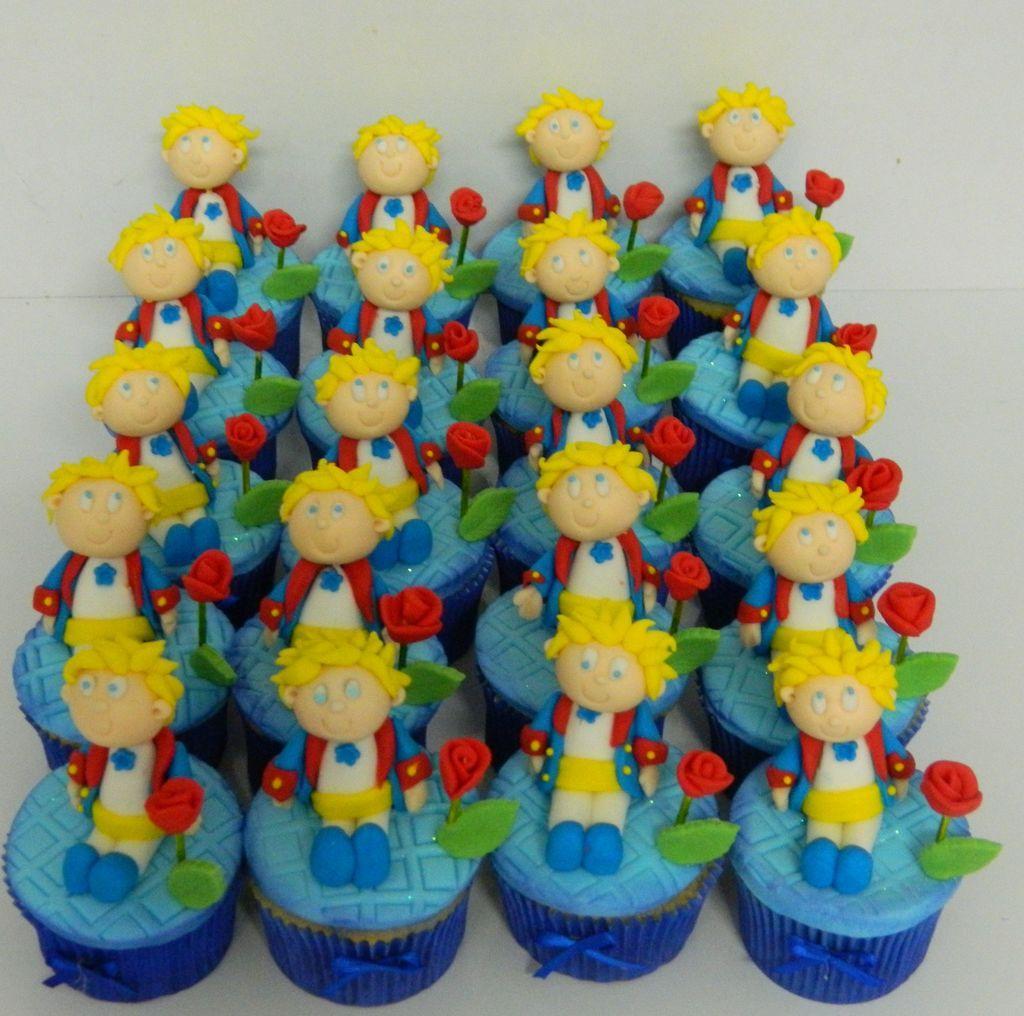Describe this image in one or two sentences. In this picture I can observe some toys. These toys are in blue and red colors. These are placed on the white color surface. In the background I can observe a wall. 